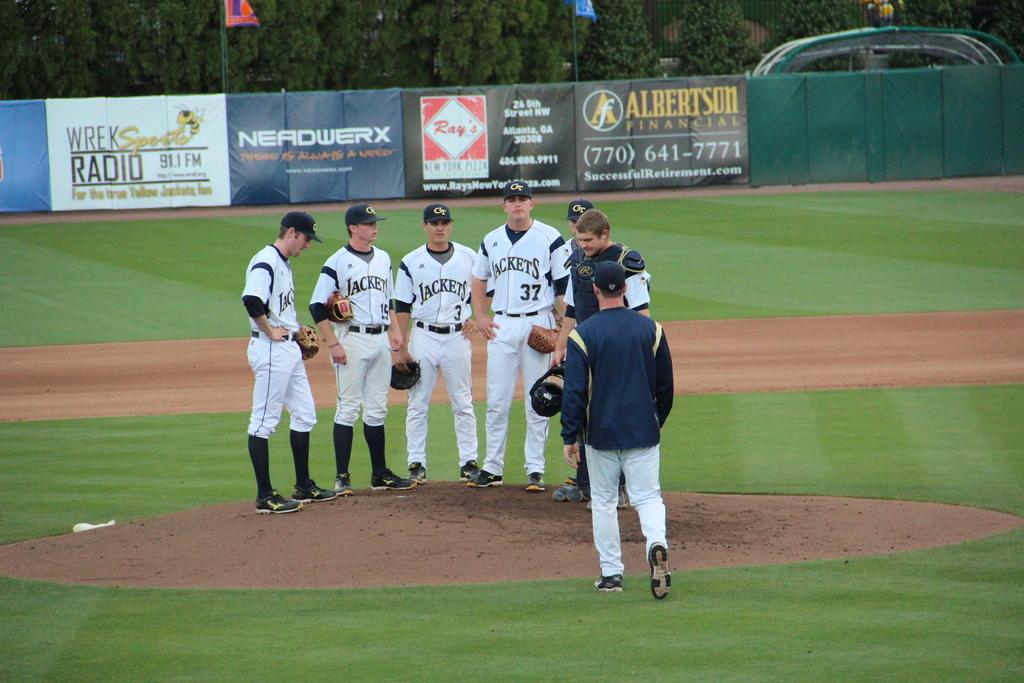<image>
Present a compact description of the photo's key features. Baseball players in Jackets uniforms stand in a group on the pitcher's mound. 